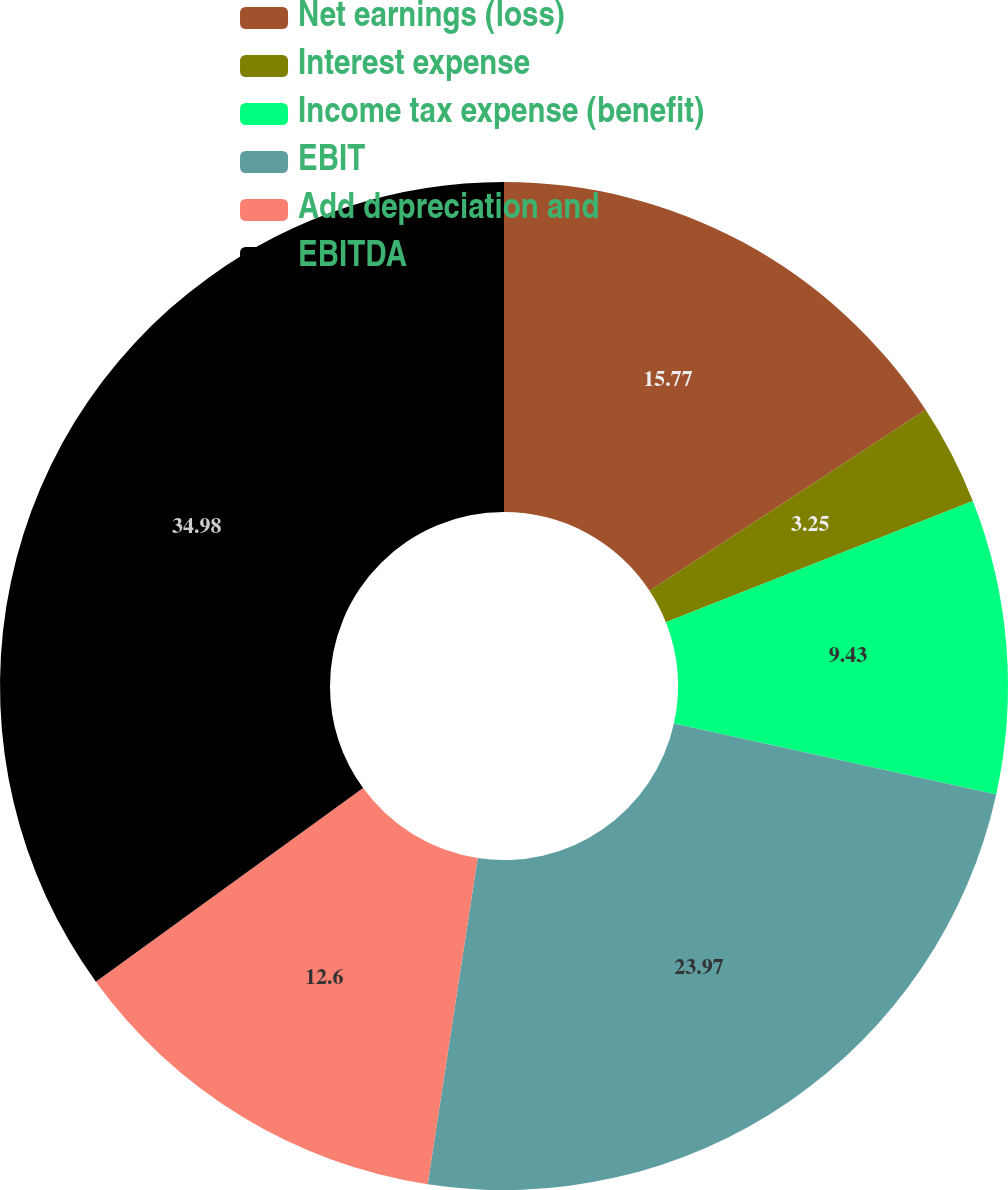Convert chart to OTSL. <chart><loc_0><loc_0><loc_500><loc_500><pie_chart><fcel>Net earnings (loss)<fcel>Interest expense<fcel>Income tax expense (benefit)<fcel>EBIT<fcel>Add depreciation and<fcel>EBITDA<nl><fcel>15.77%<fcel>3.25%<fcel>9.43%<fcel>23.97%<fcel>12.6%<fcel>34.98%<nl></chart> 